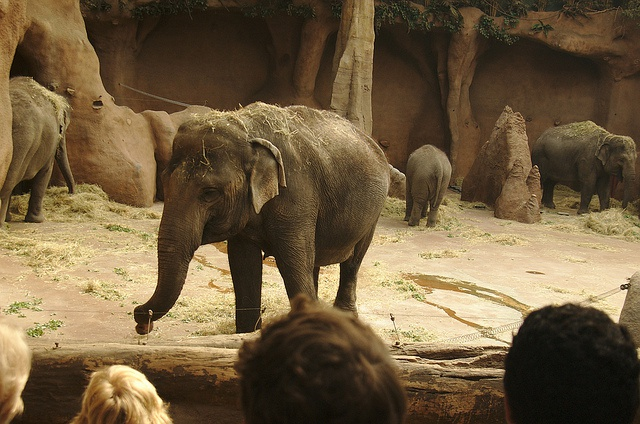Describe the objects in this image and their specific colors. I can see elephant in tan, black, olive, and maroon tones, people in tan, black, maroon, and olive tones, people in tan, black, and maroon tones, elephant in tan, black, and gray tones, and elephant in tan, olive, and black tones in this image. 